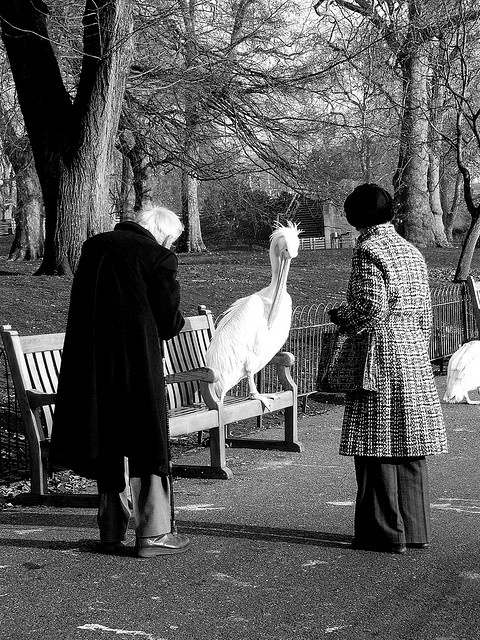Describe the objects in this image and their specific colors. I can see people in black, gray, darkgray, and lightgray tones, people in black, gray, lightgray, and darkgray tones, bench in black, lightgray, gray, and darkgray tones, bird in black, white, darkgray, and gray tones, and handbag in black, gray, darkgray, and lightgray tones in this image. 